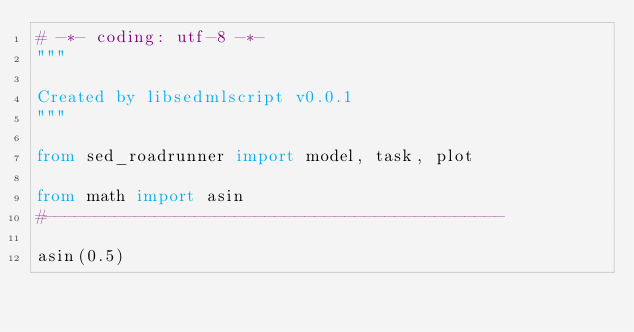<code> <loc_0><loc_0><loc_500><loc_500><_Python_># -*- coding: utf-8 -*-
"""

Created by libsedmlscript v0.0.1
"""

from sed_roadrunner import model, task, plot

from math import asin
#----------------------------------------------

asin(0.5)
</code> 